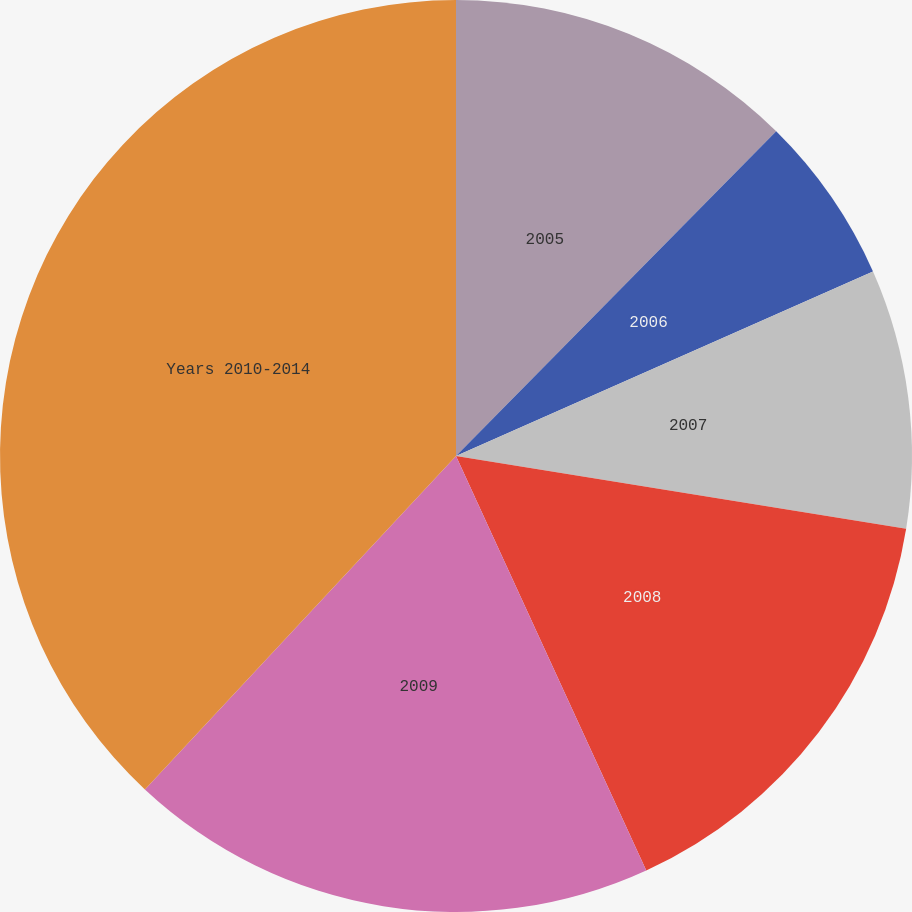Convert chart to OTSL. <chart><loc_0><loc_0><loc_500><loc_500><pie_chart><fcel>2005<fcel>2006<fcel>2007<fcel>2008<fcel>2009<fcel>Years 2010-2014<nl><fcel>12.39%<fcel>5.98%<fcel>9.18%<fcel>15.6%<fcel>18.8%<fcel>38.05%<nl></chart> 